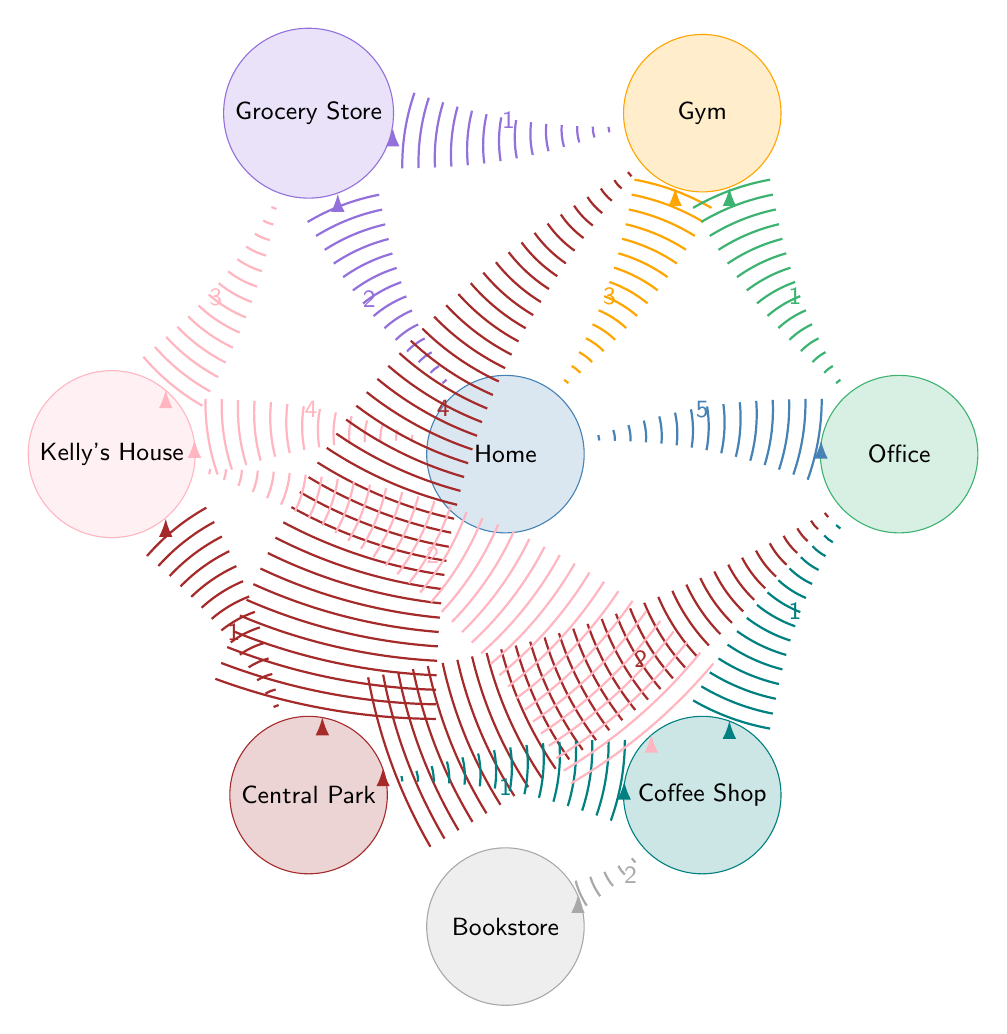What is the node that represents your home? The diagram explicitly labels one of the nodes as "Home," which is a common starting point for daily commutes.
Answer: Home Which node is directly connected to the Gym with the greatest value? Looking at the connections, the Gym is connected to the Central Park with a value of 4, which is higher than any other connection from the Gym.
Answer: Central Park How many total connections are represented in the diagram? To determine this, count each listed connection between nodes. According to the data, there are 14 connections in total.
Answer: 14 What is the value of the connection between Home and the Grocery Store? The data specifically states that the connection value from Home to the Grocery Store is 2, meaning it’s a relatively low-frequency route compared to others.
Answer: 2 Which two nodes are connected by a value of 3? Upon examining the connections, the two nodes "Home" and "Kelly's House" are linked with a connection value of 4, and "Grocery Store" and "Kelly's House" are connected with a value of 3. The answer is based on the connection points.
Answer: Grocery Store and Kelly's House What is the least commonly traveled connection from Home? The connection from Home to the Grocery Store has the lowest value of 2 when compared to other routes from Home, indicating it is the least frequently traveled based on the provided data.
Answer: Grocery Store Which location is directly connected to both the Gym and the Coffee Shop? By reviewing the diagram, the only location that has direct connections leading to both the Gym and the Coffee Shop is the Office, as it connects to the Gym with a value of 1 and to the Coffee Shop with a value of 1.
Answer: Office How many total nodes are included in the diagram? To find the total number of nodes, simply count the unique locations listed at the beginning of the data set; there are 8 unique nodes present.
Answer: 8 What is the flow of highest value from the Home? The highest connection from Home is with the Office, having a value of 5, making it the main route indicated in the diagram.
Answer: Office 